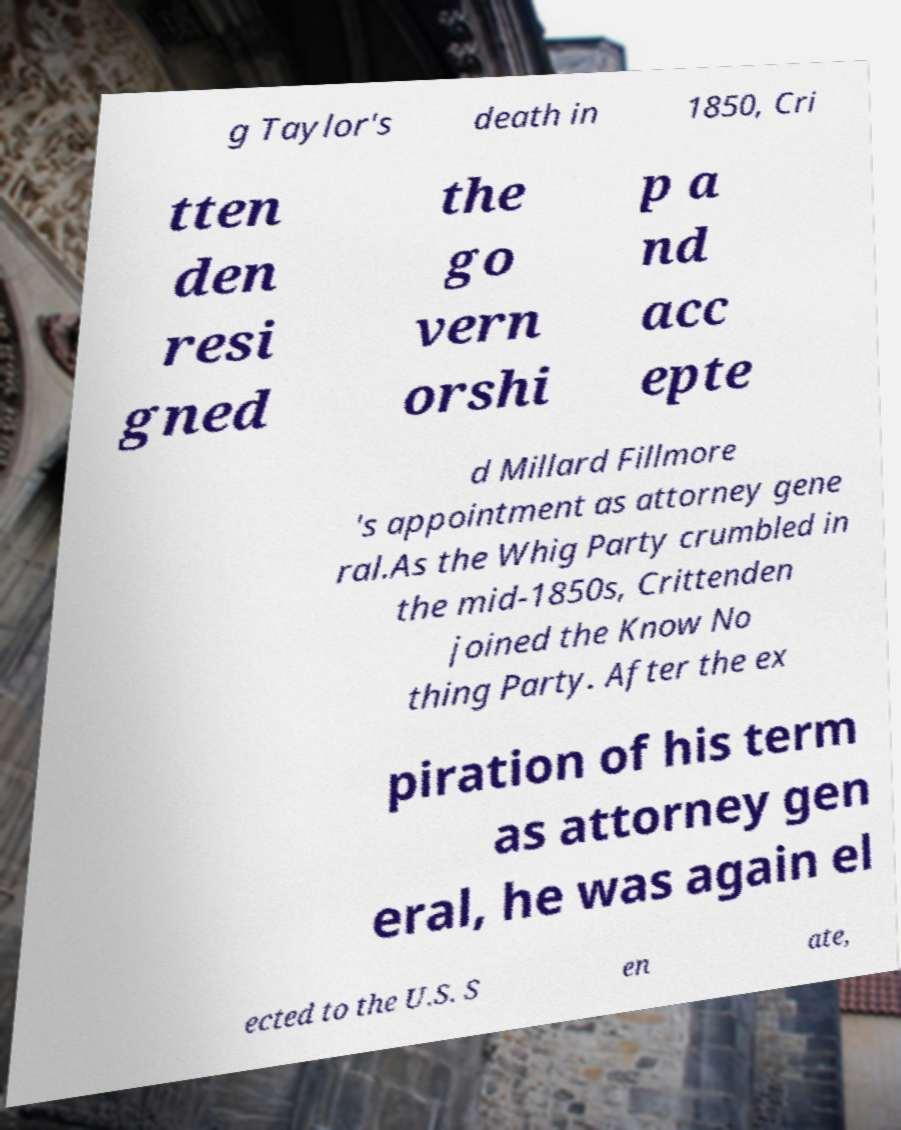Can you accurately transcribe the text from the provided image for me? g Taylor's death in 1850, Cri tten den resi gned the go vern orshi p a nd acc epte d Millard Fillmore 's appointment as attorney gene ral.As the Whig Party crumbled in the mid-1850s, Crittenden joined the Know No thing Party. After the ex piration of his term as attorney gen eral, he was again el ected to the U.S. S en ate, 